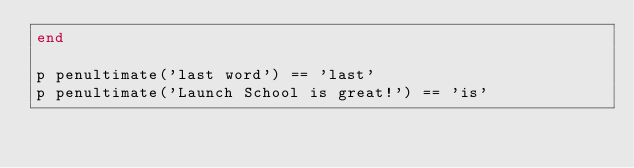<code> <loc_0><loc_0><loc_500><loc_500><_Ruby_>end

p penultimate('last word') == 'last'
p penultimate('Launch School is great!') == 'is'</code> 